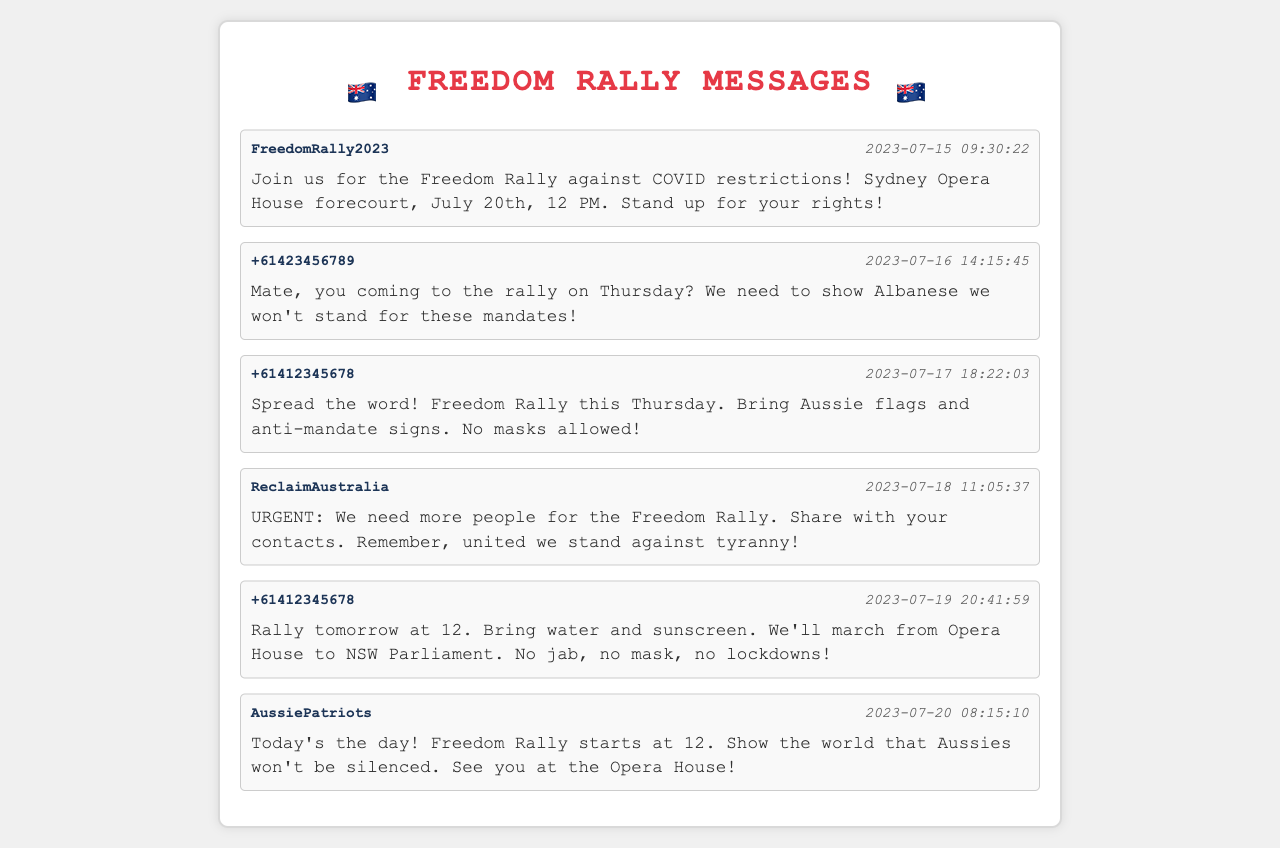What is the location of the Freedom Rally? The location is mentioned in the first message as "Sydney Opera House forecourt".
Answer: Sydney Opera House forecourt What date is the Freedom Rally scheduled? The date of the rally is specified in the first message as "July 20th".
Answer: July 20th Who sent the message asking about attending the rally? The second message is from a sender with the number "+61423456789".
Answer: +61423456789 How many messages are from the sender "+61412345678"? There are two messages from this sender in the document.
Answer: 2 What do participants need to bring according to the last message? The last message encourages participants to show they won't be silenced today at the rally.
Answer: today What time does the Freedom Rally start? The rally's start time is given in multiple messages as "12 PM".
Answer: 12 PM What is the theme of the notes regarding COVID measures? The messages express the theme of standing against COVID restrictions and mandates.
Answer: against COVID restrictions Which group is associated with the message about sharing contacts? The fourth message identifies the sender as "ReclaimAustralia".
Answer: ReclaimAustralia What is the message regarding masks? The third message specifies "No masks allowed!" as part of the rally details.
Answer: No masks allowed! 